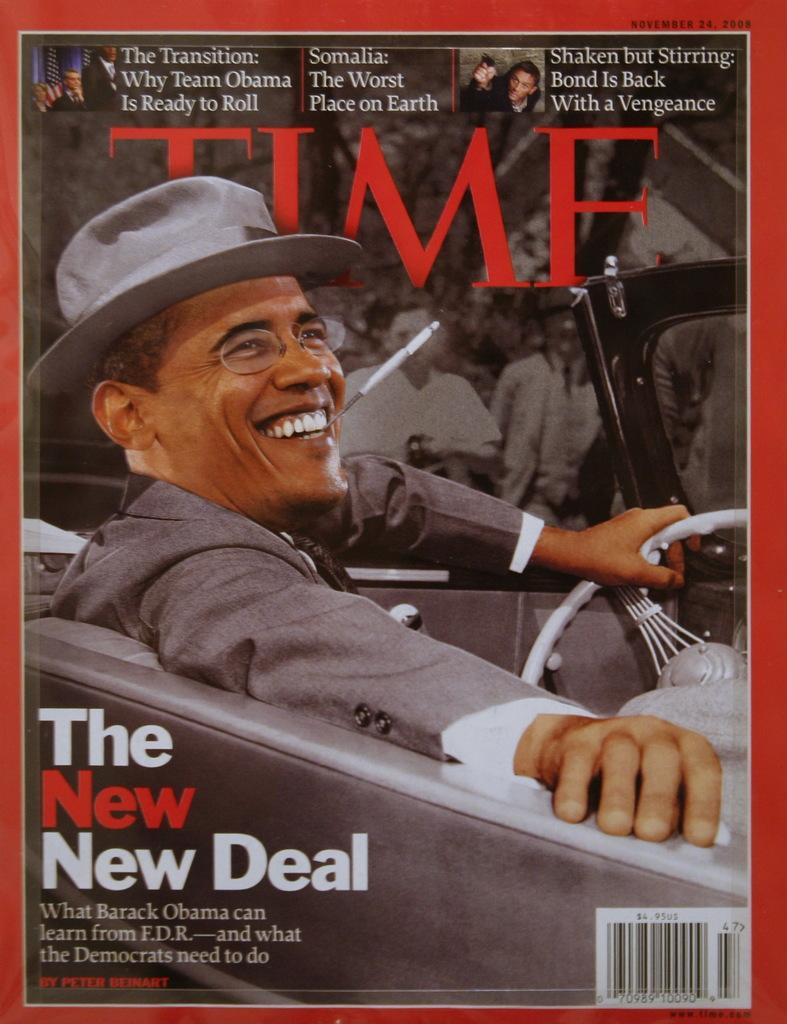<image>
Describe the image concisely. A time magazine cover with Barack Obama on the cover and the headline The New New Deal. 